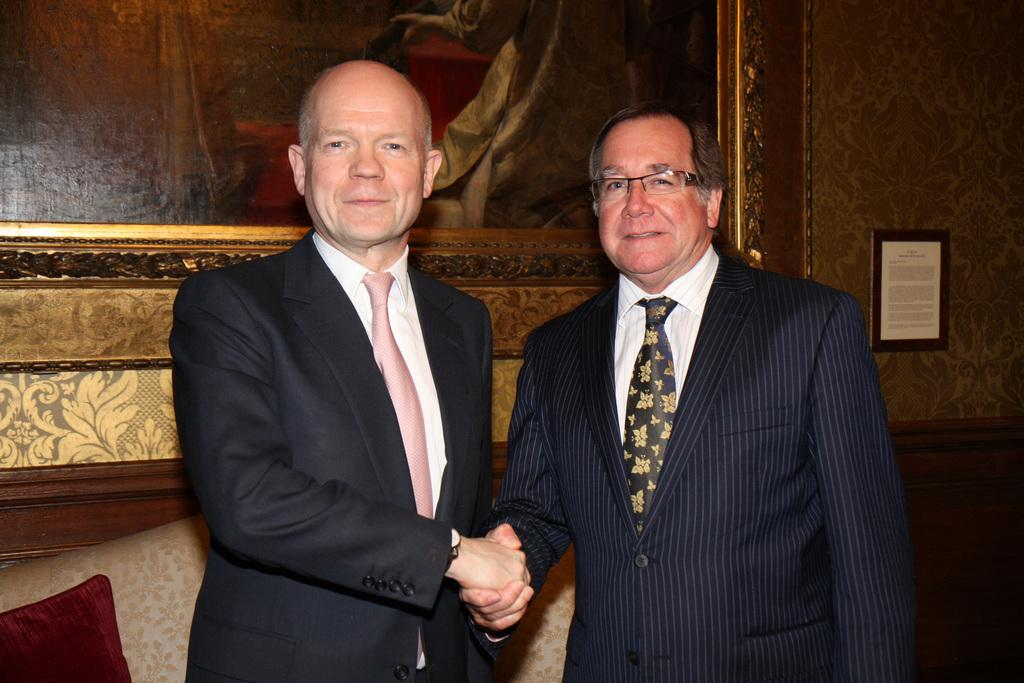What are the men in the image doing with their hands? The men are holding their hands in the image. What can be seen in the background of the image? There is a wall hanging and a couch in the background of the image. What type of quartz can be seen on the wall hanging in the image? There is no quartz present in the image, and the wall hanging does not appear to be made of quartz. What kind of creature is sitting on the couch in the background of the image? There is no creature visible in the image; only the men, their hands, the wall hanging, and the couch are present. 